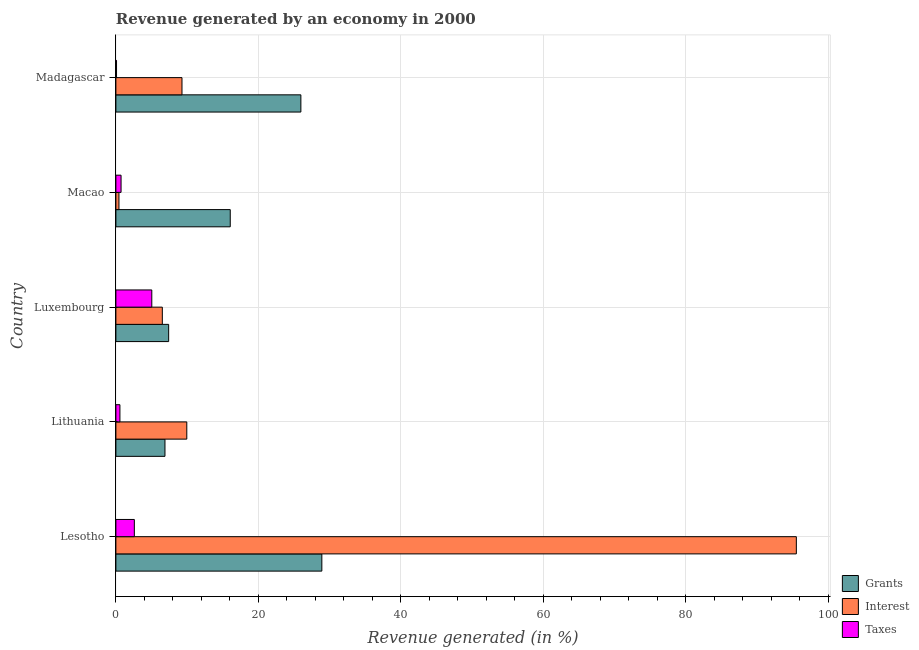How many different coloured bars are there?
Offer a terse response. 3. Are the number of bars per tick equal to the number of legend labels?
Your answer should be compact. Yes. How many bars are there on the 5th tick from the top?
Keep it short and to the point. 3. What is the label of the 1st group of bars from the top?
Keep it short and to the point. Madagascar. What is the percentage of revenue generated by taxes in Lithuania?
Ensure brevity in your answer.  0.57. Across all countries, what is the maximum percentage of revenue generated by taxes?
Your response must be concise. 5.04. Across all countries, what is the minimum percentage of revenue generated by grants?
Offer a very short reply. 6.89. In which country was the percentage of revenue generated by taxes maximum?
Your response must be concise. Luxembourg. In which country was the percentage of revenue generated by grants minimum?
Offer a terse response. Lithuania. What is the total percentage of revenue generated by taxes in the graph?
Give a very brief answer. 9.01. What is the difference between the percentage of revenue generated by interest in Lithuania and that in Macao?
Keep it short and to the point. 9.52. What is the difference between the percentage of revenue generated by taxes in Luxembourg and the percentage of revenue generated by interest in Lithuania?
Make the answer very short. -4.91. What is the average percentage of revenue generated by grants per country?
Offer a terse response. 17.04. What is the difference between the percentage of revenue generated by grants and percentage of revenue generated by interest in Lesotho?
Offer a terse response. -66.59. What is the ratio of the percentage of revenue generated by taxes in Macao to that in Madagascar?
Your answer should be compact. 7.96. Is the percentage of revenue generated by grants in Lithuania less than that in Luxembourg?
Give a very brief answer. Yes. Is the difference between the percentage of revenue generated by interest in Lithuania and Luxembourg greater than the difference between the percentage of revenue generated by grants in Lithuania and Luxembourg?
Give a very brief answer. Yes. What is the difference between the highest and the second highest percentage of revenue generated by taxes?
Ensure brevity in your answer.  2.45. What is the difference between the highest and the lowest percentage of revenue generated by interest?
Make the answer very short. 95.07. What does the 1st bar from the top in Macao represents?
Provide a short and direct response. Taxes. What does the 1st bar from the bottom in Macao represents?
Provide a short and direct response. Grants. Is it the case that in every country, the sum of the percentage of revenue generated by grants and percentage of revenue generated by interest is greater than the percentage of revenue generated by taxes?
Make the answer very short. Yes. How many bars are there?
Your answer should be compact. 15. Are the values on the major ticks of X-axis written in scientific E-notation?
Keep it short and to the point. No. Does the graph contain any zero values?
Keep it short and to the point. No. Does the graph contain grids?
Your response must be concise. Yes. Where does the legend appear in the graph?
Your answer should be compact. Bottom right. What is the title of the graph?
Give a very brief answer. Revenue generated by an economy in 2000. Does "Oil" appear as one of the legend labels in the graph?
Give a very brief answer. No. What is the label or title of the X-axis?
Your response must be concise. Revenue generated (in %). What is the Revenue generated (in %) of Grants in Lesotho?
Make the answer very short. 28.91. What is the Revenue generated (in %) of Interest in Lesotho?
Offer a terse response. 95.5. What is the Revenue generated (in %) in Taxes in Lesotho?
Ensure brevity in your answer.  2.59. What is the Revenue generated (in %) in Grants in Lithuania?
Give a very brief answer. 6.89. What is the Revenue generated (in %) in Interest in Lithuania?
Offer a terse response. 9.95. What is the Revenue generated (in %) of Taxes in Lithuania?
Your response must be concise. 0.57. What is the Revenue generated (in %) of Grants in Luxembourg?
Your answer should be very brief. 7.41. What is the Revenue generated (in %) of Interest in Luxembourg?
Offer a terse response. 6.52. What is the Revenue generated (in %) of Taxes in Luxembourg?
Keep it short and to the point. 5.04. What is the Revenue generated (in %) of Grants in Macao?
Keep it short and to the point. 16.05. What is the Revenue generated (in %) of Interest in Macao?
Keep it short and to the point. 0.43. What is the Revenue generated (in %) of Taxes in Macao?
Make the answer very short. 0.73. What is the Revenue generated (in %) of Grants in Madagascar?
Provide a succinct answer. 25.96. What is the Revenue generated (in %) in Interest in Madagascar?
Provide a succinct answer. 9.28. What is the Revenue generated (in %) of Taxes in Madagascar?
Make the answer very short. 0.09. Across all countries, what is the maximum Revenue generated (in %) of Grants?
Give a very brief answer. 28.91. Across all countries, what is the maximum Revenue generated (in %) of Interest?
Your response must be concise. 95.5. Across all countries, what is the maximum Revenue generated (in %) in Taxes?
Your answer should be very brief. 5.04. Across all countries, what is the minimum Revenue generated (in %) in Grants?
Your answer should be very brief. 6.89. Across all countries, what is the minimum Revenue generated (in %) in Interest?
Offer a very short reply. 0.43. Across all countries, what is the minimum Revenue generated (in %) in Taxes?
Offer a very short reply. 0.09. What is the total Revenue generated (in %) in Grants in the graph?
Make the answer very short. 85.21. What is the total Revenue generated (in %) of Interest in the graph?
Ensure brevity in your answer.  121.68. What is the total Revenue generated (in %) in Taxes in the graph?
Provide a short and direct response. 9.01. What is the difference between the Revenue generated (in %) of Grants in Lesotho and that in Lithuania?
Provide a short and direct response. 22.02. What is the difference between the Revenue generated (in %) of Interest in Lesotho and that in Lithuania?
Give a very brief answer. 85.55. What is the difference between the Revenue generated (in %) of Taxes in Lesotho and that in Lithuania?
Offer a very short reply. 2.02. What is the difference between the Revenue generated (in %) of Grants in Lesotho and that in Luxembourg?
Your response must be concise. 21.5. What is the difference between the Revenue generated (in %) of Interest in Lesotho and that in Luxembourg?
Ensure brevity in your answer.  88.98. What is the difference between the Revenue generated (in %) in Taxes in Lesotho and that in Luxembourg?
Make the answer very short. -2.45. What is the difference between the Revenue generated (in %) of Grants in Lesotho and that in Macao?
Your answer should be very brief. 12.86. What is the difference between the Revenue generated (in %) in Interest in Lesotho and that in Macao?
Give a very brief answer. 95.07. What is the difference between the Revenue generated (in %) of Taxes in Lesotho and that in Macao?
Make the answer very short. 1.86. What is the difference between the Revenue generated (in %) of Grants in Lesotho and that in Madagascar?
Offer a very short reply. 2.94. What is the difference between the Revenue generated (in %) of Interest in Lesotho and that in Madagascar?
Keep it short and to the point. 86.22. What is the difference between the Revenue generated (in %) of Taxes in Lesotho and that in Madagascar?
Provide a short and direct response. 2.5. What is the difference between the Revenue generated (in %) of Grants in Lithuania and that in Luxembourg?
Offer a terse response. -0.52. What is the difference between the Revenue generated (in %) in Interest in Lithuania and that in Luxembourg?
Your response must be concise. 3.43. What is the difference between the Revenue generated (in %) of Taxes in Lithuania and that in Luxembourg?
Your answer should be very brief. -4.47. What is the difference between the Revenue generated (in %) of Grants in Lithuania and that in Macao?
Give a very brief answer. -9.16. What is the difference between the Revenue generated (in %) of Interest in Lithuania and that in Macao?
Keep it short and to the point. 9.52. What is the difference between the Revenue generated (in %) of Taxes in Lithuania and that in Macao?
Offer a terse response. -0.16. What is the difference between the Revenue generated (in %) of Grants in Lithuania and that in Madagascar?
Your response must be concise. -19.07. What is the difference between the Revenue generated (in %) of Interest in Lithuania and that in Madagascar?
Make the answer very short. 0.67. What is the difference between the Revenue generated (in %) of Taxes in Lithuania and that in Madagascar?
Your response must be concise. 0.47. What is the difference between the Revenue generated (in %) of Grants in Luxembourg and that in Macao?
Offer a terse response. -8.64. What is the difference between the Revenue generated (in %) of Interest in Luxembourg and that in Macao?
Provide a succinct answer. 6.09. What is the difference between the Revenue generated (in %) in Taxes in Luxembourg and that in Macao?
Give a very brief answer. 4.31. What is the difference between the Revenue generated (in %) of Grants in Luxembourg and that in Madagascar?
Provide a succinct answer. -18.56. What is the difference between the Revenue generated (in %) in Interest in Luxembourg and that in Madagascar?
Give a very brief answer. -2.76. What is the difference between the Revenue generated (in %) of Taxes in Luxembourg and that in Madagascar?
Your answer should be very brief. 4.95. What is the difference between the Revenue generated (in %) in Grants in Macao and that in Madagascar?
Provide a short and direct response. -9.91. What is the difference between the Revenue generated (in %) in Interest in Macao and that in Madagascar?
Your response must be concise. -8.85. What is the difference between the Revenue generated (in %) of Taxes in Macao and that in Madagascar?
Make the answer very short. 0.63. What is the difference between the Revenue generated (in %) in Grants in Lesotho and the Revenue generated (in %) in Interest in Lithuania?
Ensure brevity in your answer.  18.95. What is the difference between the Revenue generated (in %) in Grants in Lesotho and the Revenue generated (in %) in Taxes in Lithuania?
Give a very brief answer. 28.34. What is the difference between the Revenue generated (in %) in Interest in Lesotho and the Revenue generated (in %) in Taxes in Lithuania?
Keep it short and to the point. 94.93. What is the difference between the Revenue generated (in %) in Grants in Lesotho and the Revenue generated (in %) in Interest in Luxembourg?
Keep it short and to the point. 22.39. What is the difference between the Revenue generated (in %) in Grants in Lesotho and the Revenue generated (in %) in Taxes in Luxembourg?
Offer a very short reply. 23.87. What is the difference between the Revenue generated (in %) of Interest in Lesotho and the Revenue generated (in %) of Taxes in Luxembourg?
Offer a terse response. 90.46. What is the difference between the Revenue generated (in %) in Grants in Lesotho and the Revenue generated (in %) in Interest in Macao?
Offer a terse response. 28.47. What is the difference between the Revenue generated (in %) in Grants in Lesotho and the Revenue generated (in %) in Taxes in Macao?
Your answer should be very brief. 28.18. What is the difference between the Revenue generated (in %) of Interest in Lesotho and the Revenue generated (in %) of Taxes in Macao?
Ensure brevity in your answer.  94.78. What is the difference between the Revenue generated (in %) of Grants in Lesotho and the Revenue generated (in %) of Interest in Madagascar?
Ensure brevity in your answer.  19.63. What is the difference between the Revenue generated (in %) of Grants in Lesotho and the Revenue generated (in %) of Taxes in Madagascar?
Your answer should be compact. 28.81. What is the difference between the Revenue generated (in %) in Interest in Lesotho and the Revenue generated (in %) in Taxes in Madagascar?
Your response must be concise. 95.41. What is the difference between the Revenue generated (in %) of Grants in Lithuania and the Revenue generated (in %) of Interest in Luxembourg?
Make the answer very short. 0.37. What is the difference between the Revenue generated (in %) of Grants in Lithuania and the Revenue generated (in %) of Taxes in Luxembourg?
Provide a short and direct response. 1.85. What is the difference between the Revenue generated (in %) in Interest in Lithuania and the Revenue generated (in %) in Taxes in Luxembourg?
Make the answer very short. 4.91. What is the difference between the Revenue generated (in %) in Grants in Lithuania and the Revenue generated (in %) in Interest in Macao?
Your answer should be compact. 6.46. What is the difference between the Revenue generated (in %) in Grants in Lithuania and the Revenue generated (in %) in Taxes in Macao?
Your response must be concise. 6.16. What is the difference between the Revenue generated (in %) of Interest in Lithuania and the Revenue generated (in %) of Taxes in Macao?
Make the answer very short. 9.23. What is the difference between the Revenue generated (in %) in Grants in Lithuania and the Revenue generated (in %) in Interest in Madagascar?
Offer a terse response. -2.39. What is the difference between the Revenue generated (in %) in Grants in Lithuania and the Revenue generated (in %) in Taxes in Madagascar?
Give a very brief answer. 6.8. What is the difference between the Revenue generated (in %) in Interest in Lithuania and the Revenue generated (in %) in Taxes in Madagascar?
Make the answer very short. 9.86. What is the difference between the Revenue generated (in %) in Grants in Luxembourg and the Revenue generated (in %) in Interest in Macao?
Offer a terse response. 6.97. What is the difference between the Revenue generated (in %) in Grants in Luxembourg and the Revenue generated (in %) in Taxes in Macao?
Your response must be concise. 6.68. What is the difference between the Revenue generated (in %) of Interest in Luxembourg and the Revenue generated (in %) of Taxes in Macao?
Give a very brief answer. 5.79. What is the difference between the Revenue generated (in %) of Grants in Luxembourg and the Revenue generated (in %) of Interest in Madagascar?
Your answer should be very brief. -1.87. What is the difference between the Revenue generated (in %) in Grants in Luxembourg and the Revenue generated (in %) in Taxes in Madagascar?
Your answer should be compact. 7.31. What is the difference between the Revenue generated (in %) of Interest in Luxembourg and the Revenue generated (in %) of Taxes in Madagascar?
Your answer should be compact. 6.43. What is the difference between the Revenue generated (in %) of Grants in Macao and the Revenue generated (in %) of Interest in Madagascar?
Offer a very short reply. 6.77. What is the difference between the Revenue generated (in %) in Grants in Macao and the Revenue generated (in %) in Taxes in Madagascar?
Your answer should be very brief. 15.96. What is the difference between the Revenue generated (in %) in Interest in Macao and the Revenue generated (in %) in Taxes in Madagascar?
Make the answer very short. 0.34. What is the average Revenue generated (in %) of Grants per country?
Make the answer very short. 17.04. What is the average Revenue generated (in %) in Interest per country?
Your answer should be compact. 24.34. What is the average Revenue generated (in %) of Taxes per country?
Provide a short and direct response. 1.8. What is the difference between the Revenue generated (in %) of Grants and Revenue generated (in %) of Interest in Lesotho?
Offer a very short reply. -66.6. What is the difference between the Revenue generated (in %) in Grants and Revenue generated (in %) in Taxes in Lesotho?
Provide a succinct answer. 26.32. What is the difference between the Revenue generated (in %) of Interest and Revenue generated (in %) of Taxes in Lesotho?
Your response must be concise. 92.91. What is the difference between the Revenue generated (in %) of Grants and Revenue generated (in %) of Interest in Lithuania?
Your response must be concise. -3.06. What is the difference between the Revenue generated (in %) of Grants and Revenue generated (in %) of Taxes in Lithuania?
Keep it short and to the point. 6.32. What is the difference between the Revenue generated (in %) in Interest and Revenue generated (in %) in Taxes in Lithuania?
Offer a very short reply. 9.39. What is the difference between the Revenue generated (in %) in Grants and Revenue generated (in %) in Interest in Luxembourg?
Make the answer very short. 0.89. What is the difference between the Revenue generated (in %) in Grants and Revenue generated (in %) in Taxes in Luxembourg?
Offer a very short reply. 2.37. What is the difference between the Revenue generated (in %) in Interest and Revenue generated (in %) in Taxes in Luxembourg?
Keep it short and to the point. 1.48. What is the difference between the Revenue generated (in %) of Grants and Revenue generated (in %) of Interest in Macao?
Ensure brevity in your answer.  15.62. What is the difference between the Revenue generated (in %) of Grants and Revenue generated (in %) of Taxes in Macao?
Ensure brevity in your answer.  15.32. What is the difference between the Revenue generated (in %) in Interest and Revenue generated (in %) in Taxes in Macao?
Your response must be concise. -0.29. What is the difference between the Revenue generated (in %) of Grants and Revenue generated (in %) of Interest in Madagascar?
Ensure brevity in your answer.  16.69. What is the difference between the Revenue generated (in %) of Grants and Revenue generated (in %) of Taxes in Madagascar?
Your answer should be compact. 25.87. What is the difference between the Revenue generated (in %) of Interest and Revenue generated (in %) of Taxes in Madagascar?
Make the answer very short. 9.19. What is the ratio of the Revenue generated (in %) of Grants in Lesotho to that in Lithuania?
Offer a very short reply. 4.2. What is the ratio of the Revenue generated (in %) of Interest in Lesotho to that in Lithuania?
Keep it short and to the point. 9.6. What is the ratio of the Revenue generated (in %) in Taxes in Lesotho to that in Lithuania?
Give a very brief answer. 4.58. What is the ratio of the Revenue generated (in %) of Grants in Lesotho to that in Luxembourg?
Your answer should be compact. 3.9. What is the ratio of the Revenue generated (in %) of Interest in Lesotho to that in Luxembourg?
Offer a terse response. 14.65. What is the ratio of the Revenue generated (in %) in Taxes in Lesotho to that in Luxembourg?
Your response must be concise. 0.51. What is the ratio of the Revenue generated (in %) in Grants in Lesotho to that in Macao?
Provide a succinct answer. 1.8. What is the ratio of the Revenue generated (in %) of Interest in Lesotho to that in Macao?
Provide a succinct answer. 221.6. What is the ratio of the Revenue generated (in %) in Taxes in Lesotho to that in Macao?
Provide a short and direct response. 3.57. What is the ratio of the Revenue generated (in %) of Grants in Lesotho to that in Madagascar?
Your answer should be very brief. 1.11. What is the ratio of the Revenue generated (in %) of Interest in Lesotho to that in Madagascar?
Keep it short and to the point. 10.29. What is the ratio of the Revenue generated (in %) of Taxes in Lesotho to that in Madagascar?
Ensure brevity in your answer.  28.43. What is the ratio of the Revenue generated (in %) of Grants in Lithuania to that in Luxembourg?
Keep it short and to the point. 0.93. What is the ratio of the Revenue generated (in %) in Interest in Lithuania to that in Luxembourg?
Offer a terse response. 1.53. What is the ratio of the Revenue generated (in %) in Taxes in Lithuania to that in Luxembourg?
Provide a short and direct response. 0.11. What is the ratio of the Revenue generated (in %) in Grants in Lithuania to that in Macao?
Ensure brevity in your answer.  0.43. What is the ratio of the Revenue generated (in %) of Interest in Lithuania to that in Macao?
Your answer should be compact. 23.09. What is the ratio of the Revenue generated (in %) of Taxes in Lithuania to that in Macao?
Offer a very short reply. 0.78. What is the ratio of the Revenue generated (in %) of Grants in Lithuania to that in Madagascar?
Provide a short and direct response. 0.27. What is the ratio of the Revenue generated (in %) in Interest in Lithuania to that in Madagascar?
Ensure brevity in your answer.  1.07. What is the ratio of the Revenue generated (in %) in Taxes in Lithuania to that in Madagascar?
Keep it short and to the point. 6.21. What is the ratio of the Revenue generated (in %) in Grants in Luxembourg to that in Macao?
Make the answer very short. 0.46. What is the ratio of the Revenue generated (in %) in Interest in Luxembourg to that in Macao?
Your answer should be compact. 15.12. What is the ratio of the Revenue generated (in %) of Taxes in Luxembourg to that in Macao?
Give a very brief answer. 6.95. What is the ratio of the Revenue generated (in %) in Grants in Luxembourg to that in Madagascar?
Provide a succinct answer. 0.29. What is the ratio of the Revenue generated (in %) in Interest in Luxembourg to that in Madagascar?
Provide a succinct answer. 0.7. What is the ratio of the Revenue generated (in %) in Taxes in Luxembourg to that in Madagascar?
Offer a terse response. 55.32. What is the ratio of the Revenue generated (in %) in Grants in Macao to that in Madagascar?
Make the answer very short. 0.62. What is the ratio of the Revenue generated (in %) of Interest in Macao to that in Madagascar?
Your answer should be very brief. 0.05. What is the ratio of the Revenue generated (in %) of Taxes in Macao to that in Madagascar?
Your response must be concise. 7.96. What is the difference between the highest and the second highest Revenue generated (in %) of Grants?
Keep it short and to the point. 2.94. What is the difference between the highest and the second highest Revenue generated (in %) of Interest?
Make the answer very short. 85.55. What is the difference between the highest and the second highest Revenue generated (in %) in Taxes?
Keep it short and to the point. 2.45. What is the difference between the highest and the lowest Revenue generated (in %) of Grants?
Provide a succinct answer. 22.02. What is the difference between the highest and the lowest Revenue generated (in %) of Interest?
Provide a succinct answer. 95.07. What is the difference between the highest and the lowest Revenue generated (in %) in Taxes?
Make the answer very short. 4.95. 